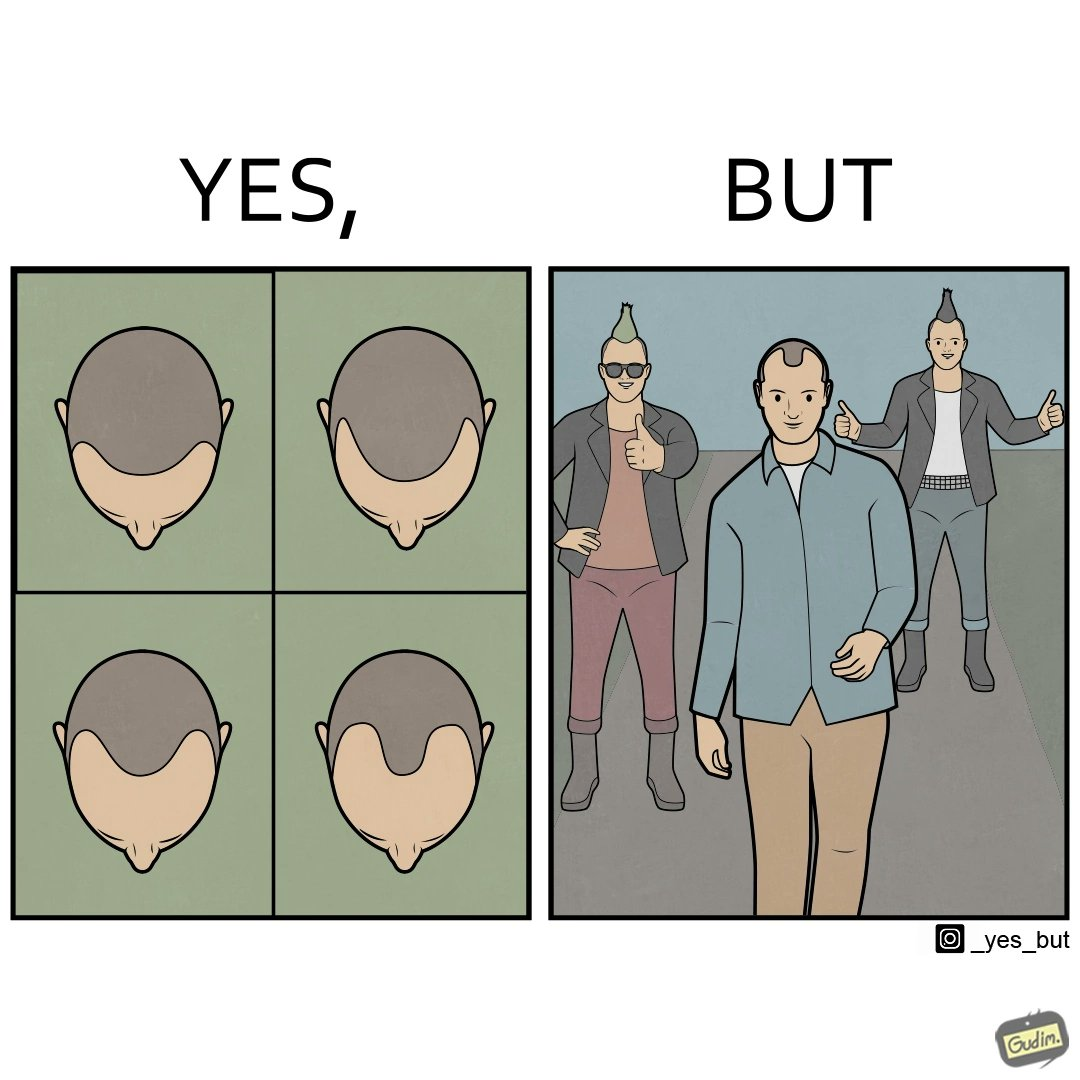Compare the left and right sides of this image. In the left part of the image: Images of a man with pattern baldness In the right part of the image: Three men with unusual hairstyles 